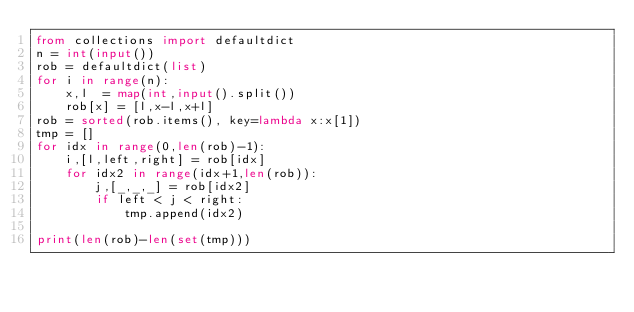Convert code to text. <code><loc_0><loc_0><loc_500><loc_500><_Python_>from collections import defaultdict
n = int(input())
rob = defaultdict(list)
for i in range(n):
    x,l  = map(int,input().split())
    rob[x] = [l,x-l,x+l]
rob = sorted(rob.items(), key=lambda x:x[1])
tmp = []
for idx in range(0,len(rob)-1):
    i,[l,left,right] = rob[idx]
    for idx2 in range(idx+1,len(rob)):
        j,[_,_,_] = rob[idx2]
        if left < j < right:
            tmp.append(idx2)

print(len(rob)-len(set(tmp)))</code> 